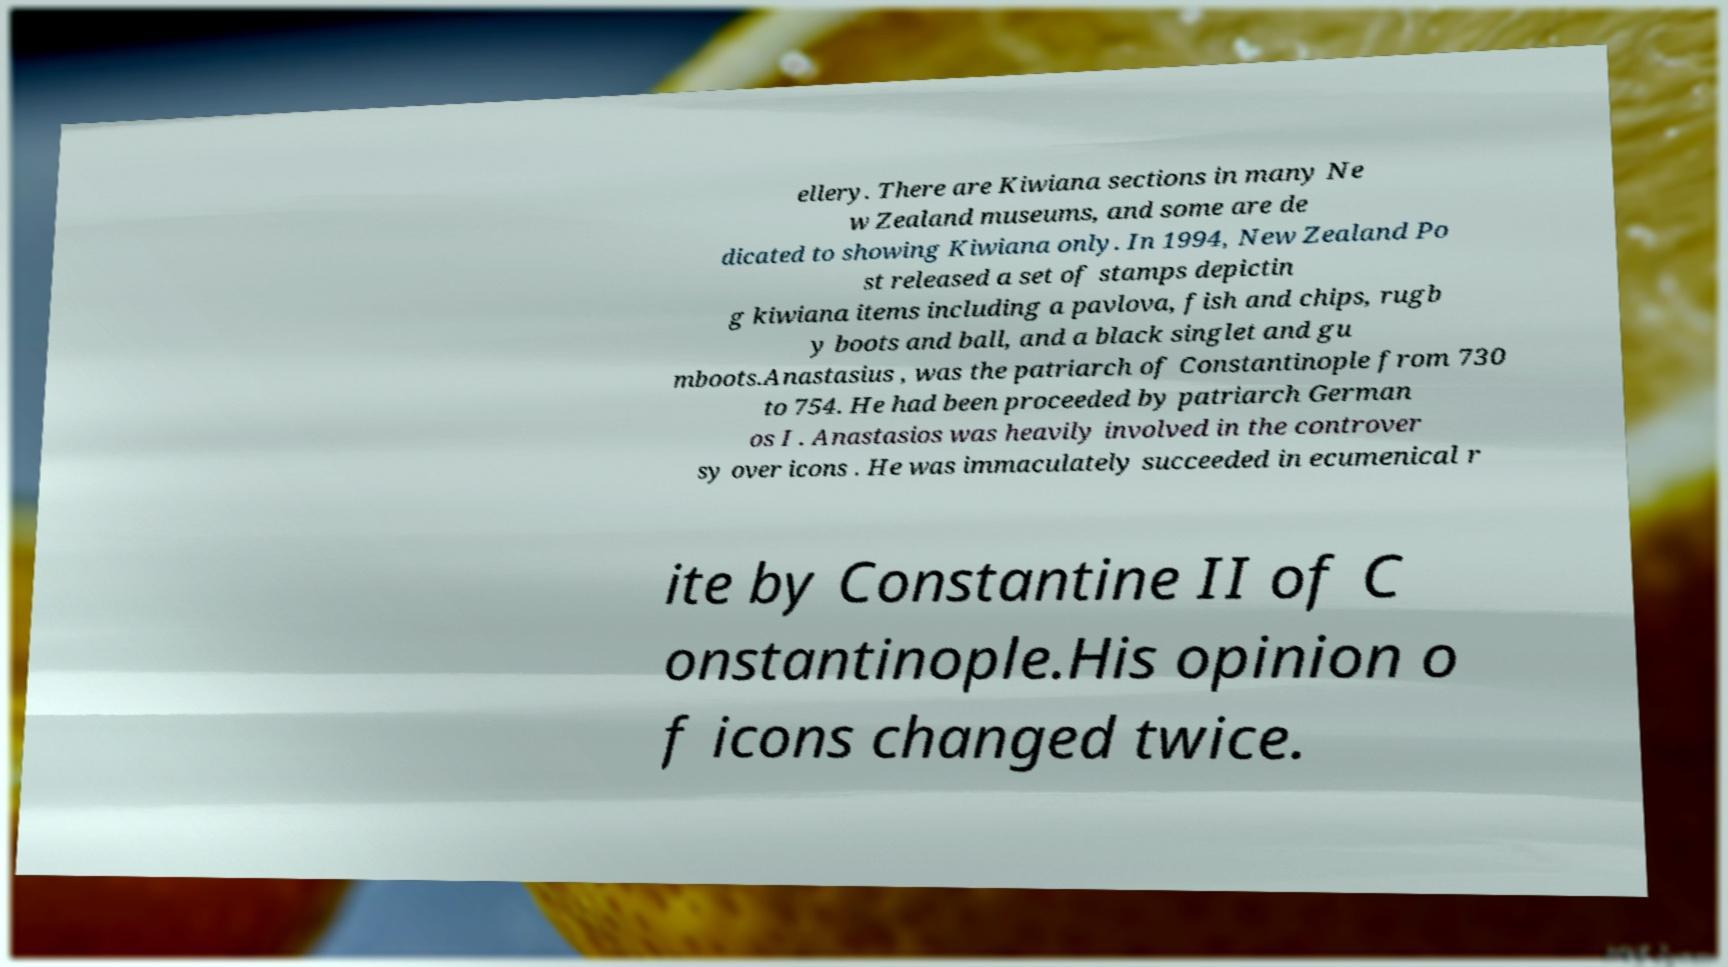Can you read and provide the text displayed in the image?This photo seems to have some interesting text. Can you extract and type it out for me? ellery. There are Kiwiana sections in many Ne w Zealand museums, and some are de dicated to showing Kiwiana only. In 1994, New Zealand Po st released a set of stamps depictin g kiwiana items including a pavlova, fish and chips, rugb y boots and ball, and a black singlet and gu mboots.Anastasius , was the patriarch of Constantinople from 730 to 754. He had been proceeded by patriarch German os I . Anastasios was heavily involved in the controver sy over icons . He was immaculately succeeded in ecumenical r ite by Constantine II of C onstantinople.His opinion o f icons changed twice. 